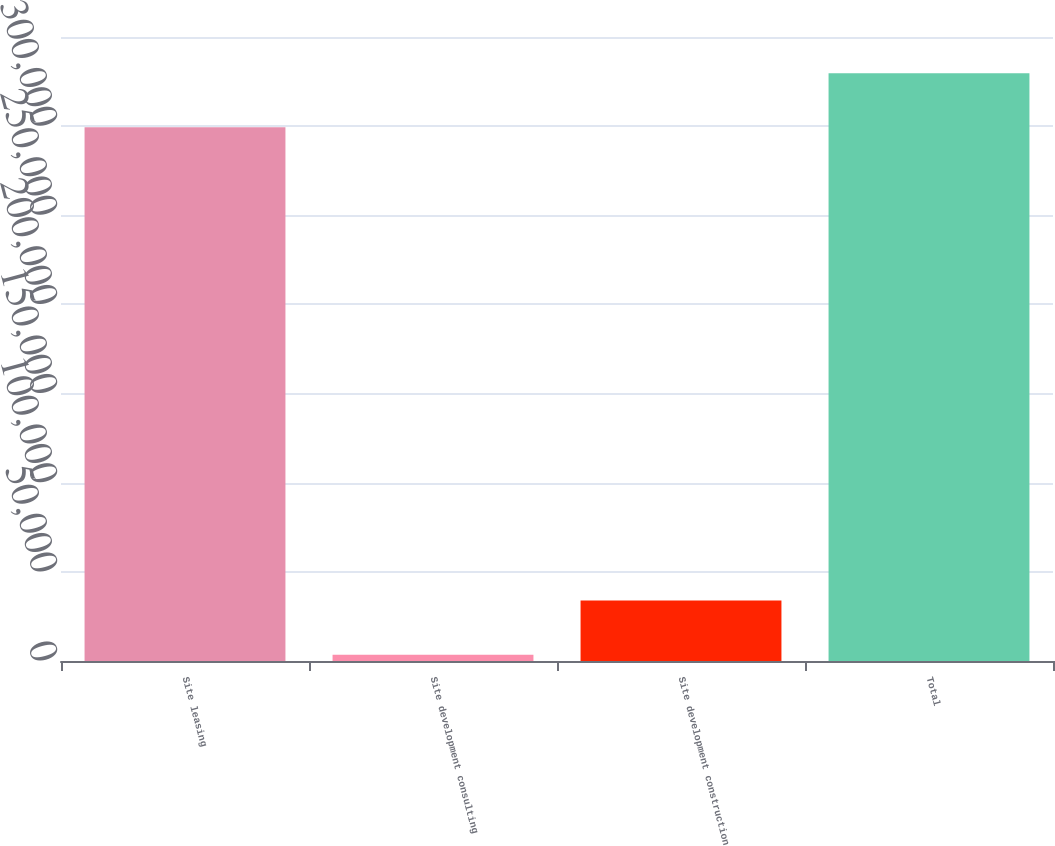Convert chart to OTSL. <chart><loc_0><loc_0><loc_500><loc_500><bar_chart><fcel>Site leasing<fcel>Site development consulting<fcel>Site development construction<fcel>Total<nl><fcel>299366<fcel>3542<fcel>33866.7<fcel>329691<nl></chart> 